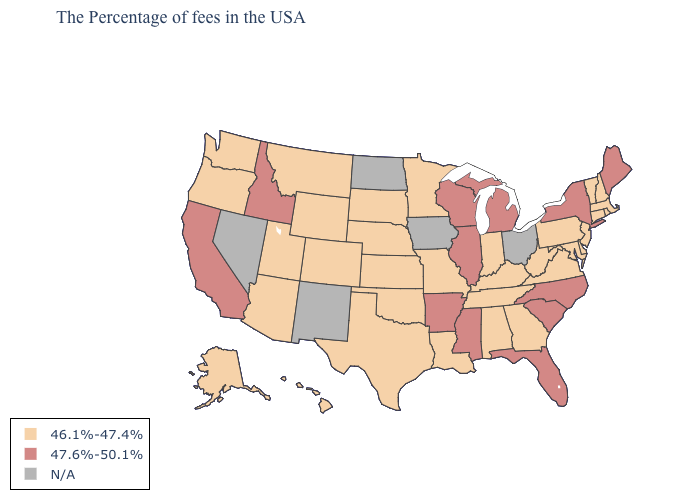What is the value of New Hampshire?
Keep it brief. 46.1%-47.4%. Does Wyoming have the lowest value in the West?
Be succinct. Yes. Which states have the lowest value in the MidWest?
Answer briefly. Indiana, Missouri, Minnesota, Kansas, Nebraska, South Dakota. What is the value of Alabama?
Concise answer only. 46.1%-47.4%. What is the value of Maryland?
Concise answer only. 46.1%-47.4%. Name the states that have a value in the range N/A?
Be succinct. Ohio, Iowa, North Dakota, New Mexico, Nevada. Name the states that have a value in the range 46.1%-47.4%?
Answer briefly. Massachusetts, Rhode Island, New Hampshire, Vermont, Connecticut, New Jersey, Delaware, Maryland, Pennsylvania, Virginia, West Virginia, Georgia, Kentucky, Indiana, Alabama, Tennessee, Louisiana, Missouri, Minnesota, Kansas, Nebraska, Oklahoma, Texas, South Dakota, Wyoming, Colorado, Utah, Montana, Arizona, Washington, Oregon, Alaska, Hawaii. What is the value of South Dakota?
Quick response, please. 46.1%-47.4%. What is the highest value in states that border Vermont?
Be succinct. 47.6%-50.1%. What is the value of Nevada?
Answer briefly. N/A. What is the value of Louisiana?
Give a very brief answer. 46.1%-47.4%. Which states hav the highest value in the Northeast?
Be succinct. Maine, New York. Does Nebraska have the lowest value in the USA?
Quick response, please. Yes. 